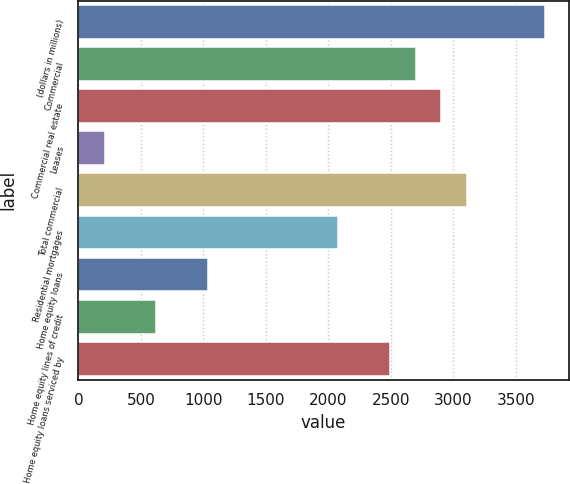Convert chart. <chart><loc_0><loc_0><loc_500><loc_500><bar_chart><fcel>(dollars in millions)<fcel>Commercial<fcel>Commercial real estate<fcel>Leases<fcel>Total commercial<fcel>Residential mortgages<fcel>Home equity loans<fcel>Home equity lines of credit<fcel>Home equity loans serviced by<nl><fcel>3734.2<fcel>2697.2<fcel>2904.6<fcel>208.4<fcel>3112<fcel>2075<fcel>1038<fcel>623.2<fcel>2489.8<nl></chart> 